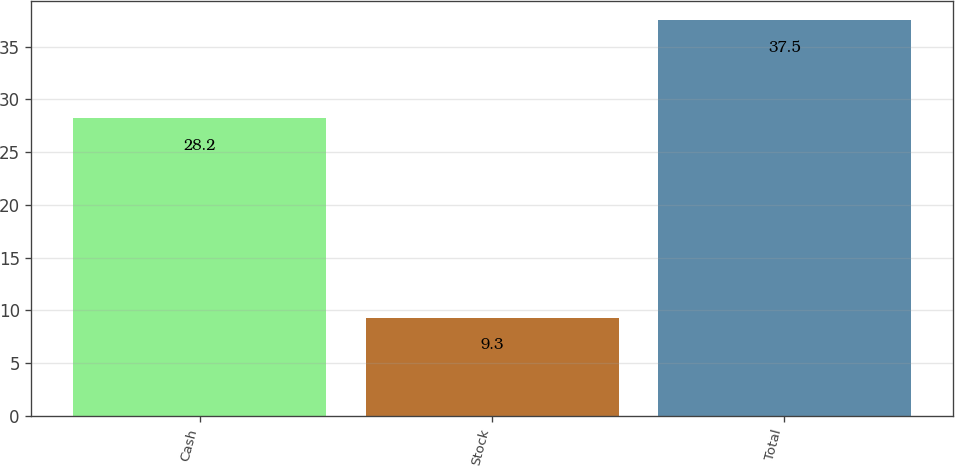<chart> <loc_0><loc_0><loc_500><loc_500><bar_chart><fcel>Cash<fcel>Stock<fcel>Total<nl><fcel>28.2<fcel>9.3<fcel>37.5<nl></chart> 